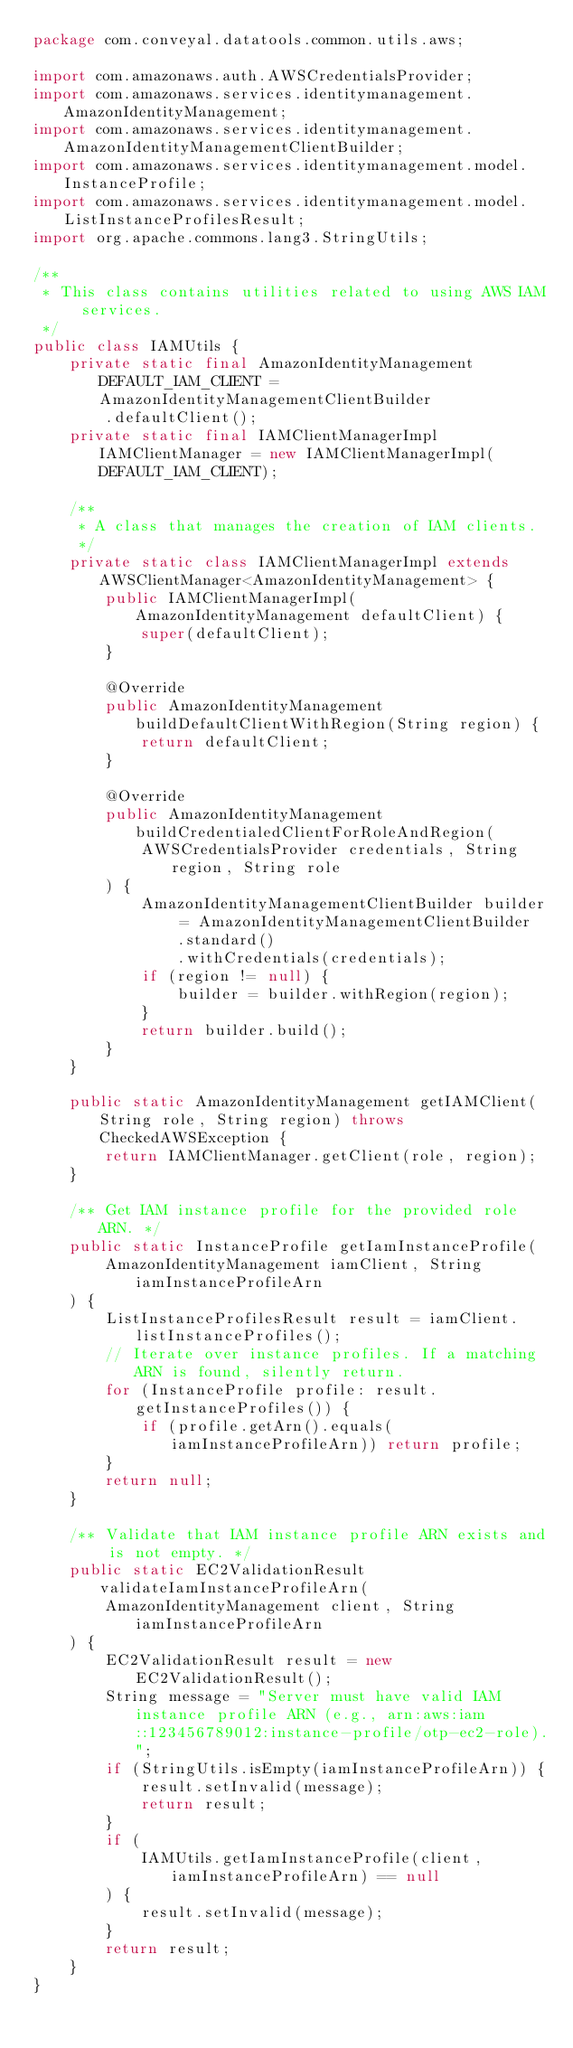Convert code to text. <code><loc_0><loc_0><loc_500><loc_500><_Java_>package com.conveyal.datatools.common.utils.aws;

import com.amazonaws.auth.AWSCredentialsProvider;
import com.amazonaws.services.identitymanagement.AmazonIdentityManagement;
import com.amazonaws.services.identitymanagement.AmazonIdentityManagementClientBuilder;
import com.amazonaws.services.identitymanagement.model.InstanceProfile;
import com.amazonaws.services.identitymanagement.model.ListInstanceProfilesResult;
import org.apache.commons.lang3.StringUtils;

/**
 * This class contains utilities related to using AWS IAM services.
 */
public class IAMUtils {
    private static final AmazonIdentityManagement DEFAULT_IAM_CLIENT = AmazonIdentityManagementClientBuilder
        .defaultClient();
    private static final IAMClientManagerImpl IAMClientManager = new IAMClientManagerImpl(DEFAULT_IAM_CLIENT);

    /**
     * A class that manages the creation of IAM clients.
     */
    private static class IAMClientManagerImpl extends AWSClientManager<AmazonIdentityManagement> {
        public IAMClientManagerImpl(AmazonIdentityManagement defaultClient) {
            super(defaultClient);
        }

        @Override
        public AmazonIdentityManagement buildDefaultClientWithRegion(String region) {
            return defaultClient;
        }

        @Override
        public AmazonIdentityManagement buildCredentialedClientForRoleAndRegion(
            AWSCredentialsProvider credentials, String region, String role
        ) {
            AmazonIdentityManagementClientBuilder builder = AmazonIdentityManagementClientBuilder
                .standard()
                .withCredentials(credentials);
            if (region != null) {
                builder = builder.withRegion(region);
            }
            return builder.build();
        }
    }

    public static AmazonIdentityManagement getIAMClient(String role, String region) throws CheckedAWSException {
        return IAMClientManager.getClient(role, region);
    }

    /** Get IAM instance profile for the provided role ARN. */
    public static InstanceProfile getIamInstanceProfile(
        AmazonIdentityManagement iamClient, String iamInstanceProfileArn
    ) {
        ListInstanceProfilesResult result = iamClient.listInstanceProfiles();
        // Iterate over instance profiles. If a matching ARN is found, silently return.
        for (InstanceProfile profile: result.getInstanceProfiles()) {
            if (profile.getArn().equals(iamInstanceProfileArn)) return profile;
        }
        return null;
    }

    /** Validate that IAM instance profile ARN exists and is not empty. */
    public static EC2ValidationResult validateIamInstanceProfileArn(
        AmazonIdentityManagement client, String iamInstanceProfileArn
    ) {
        EC2ValidationResult result = new EC2ValidationResult();
        String message = "Server must have valid IAM instance profile ARN (e.g., arn:aws:iam::123456789012:instance-profile/otp-ec2-role).";
        if (StringUtils.isEmpty(iamInstanceProfileArn)) {
            result.setInvalid(message);
            return result;
        }
        if (
            IAMUtils.getIamInstanceProfile(client, iamInstanceProfileArn) == null
        ) {
            result.setInvalid(message);
        }
        return result;
    }
}
</code> 